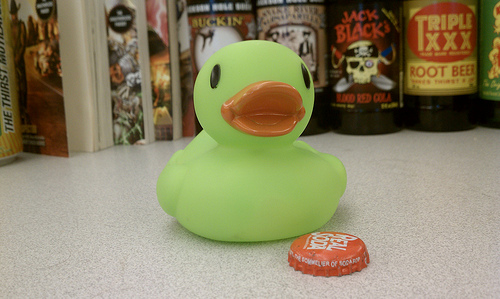<image>
Is there a label under the bottle cap? No. The label is not positioned under the bottle cap. The vertical relationship between these objects is different. 